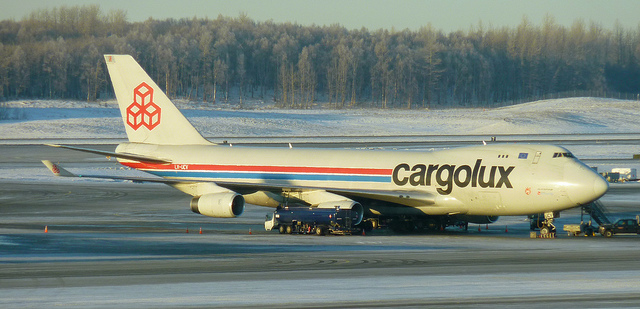Please identify all text content in this image. cargolux 